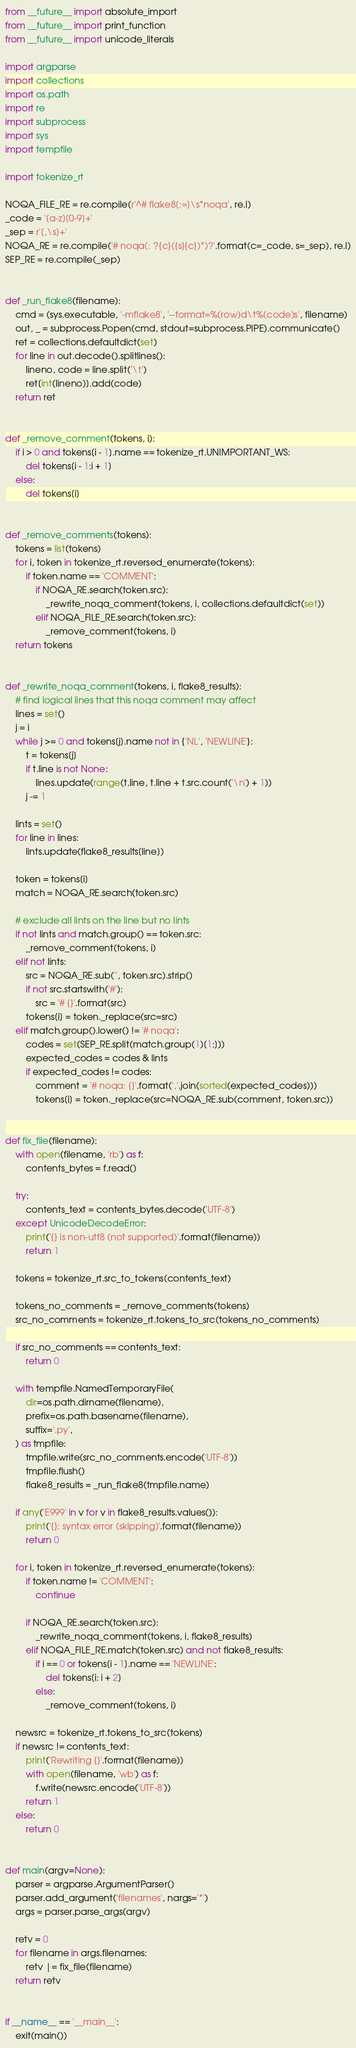<code> <loc_0><loc_0><loc_500><loc_500><_Python_>from __future__ import absolute_import
from __future__ import print_function
from __future__ import unicode_literals

import argparse
import collections
import os.path
import re
import subprocess
import sys
import tempfile

import tokenize_rt

NOQA_FILE_RE = re.compile(r'^# flake8[:=]\s*noqa', re.I)
_code = '[a-z][0-9]+'
_sep = r'[,\s]+'
NOQA_RE = re.compile('# noqa(: ?{c}({s}{c})*)?'.format(c=_code, s=_sep), re.I)
SEP_RE = re.compile(_sep)


def _run_flake8(filename):
    cmd = (sys.executable, '-mflake8', '--format=%(row)d\t%(code)s', filename)
    out, _ = subprocess.Popen(cmd, stdout=subprocess.PIPE).communicate()
    ret = collections.defaultdict(set)
    for line in out.decode().splitlines():
        lineno, code = line.split('\t')
        ret[int(lineno)].add(code)
    return ret


def _remove_comment(tokens, i):
    if i > 0 and tokens[i - 1].name == tokenize_rt.UNIMPORTANT_WS:
        del tokens[i - 1:i + 1]
    else:
        del tokens[i]


def _remove_comments(tokens):
    tokens = list(tokens)
    for i, token in tokenize_rt.reversed_enumerate(tokens):
        if token.name == 'COMMENT':
            if NOQA_RE.search(token.src):
                _rewrite_noqa_comment(tokens, i, collections.defaultdict(set))
            elif NOQA_FILE_RE.search(token.src):
                _remove_comment(tokens, i)
    return tokens


def _rewrite_noqa_comment(tokens, i, flake8_results):
    # find logical lines that this noqa comment may affect
    lines = set()
    j = i
    while j >= 0 and tokens[j].name not in {'NL', 'NEWLINE'}:
        t = tokens[j]
        if t.line is not None:
            lines.update(range(t.line, t.line + t.src.count('\n') + 1))
        j -= 1

    lints = set()
    for line in lines:
        lints.update(flake8_results[line])

    token = tokens[i]
    match = NOQA_RE.search(token.src)

    # exclude all lints on the line but no lints
    if not lints and match.group() == token.src:
        _remove_comment(tokens, i)
    elif not lints:
        src = NOQA_RE.sub('', token.src).strip()
        if not src.startswith('#'):
            src = '# {}'.format(src)
        tokens[i] = token._replace(src=src)
    elif match.group().lower() != '# noqa':
        codes = set(SEP_RE.split(match.group(1)[1:]))
        expected_codes = codes & lints
        if expected_codes != codes:
            comment = '# noqa: {}'.format(','.join(sorted(expected_codes)))
            tokens[i] = token._replace(src=NOQA_RE.sub(comment, token.src))


def fix_file(filename):
    with open(filename, 'rb') as f:
        contents_bytes = f.read()

    try:
        contents_text = contents_bytes.decode('UTF-8')
    except UnicodeDecodeError:
        print('{} is non-utf8 (not supported)'.format(filename))
        return 1

    tokens = tokenize_rt.src_to_tokens(contents_text)

    tokens_no_comments = _remove_comments(tokens)
    src_no_comments = tokenize_rt.tokens_to_src(tokens_no_comments)

    if src_no_comments == contents_text:
        return 0

    with tempfile.NamedTemporaryFile(
        dir=os.path.dirname(filename),
        prefix=os.path.basename(filename),
        suffix='.py',
    ) as tmpfile:
        tmpfile.write(src_no_comments.encode('UTF-8'))
        tmpfile.flush()
        flake8_results = _run_flake8(tmpfile.name)

    if any('E999' in v for v in flake8_results.values()):
        print('{}: syntax error (skipping)'.format(filename))
        return 0

    for i, token in tokenize_rt.reversed_enumerate(tokens):
        if token.name != 'COMMENT':
            continue

        if NOQA_RE.search(token.src):
            _rewrite_noqa_comment(tokens, i, flake8_results)
        elif NOQA_FILE_RE.match(token.src) and not flake8_results:
            if i == 0 or tokens[i - 1].name == 'NEWLINE':
                del tokens[i: i + 2]
            else:
                _remove_comment(tokens, i)

    newsrc = tokenize_rt.tokens_to_src(tokens)
    if newsrc != contents_text:
        print('Rewriting {}'.format(filename))
        with open(filename, 'wb') as f:
            f.write(newsrc.encode('UTF-8'))
        return 1
    else:
        return 0


def main(argv=None):
    parser = argparse.ArgumentParser()
    parser.add_argument('filenames', nargs='*')
    args = parser.parse_args(argv)

    retv = 0
    for filename in args.filenames:
        retv |= fix_file(filename)
    return retv


if __name__ == '__main__':
    exit(main())
</code> 